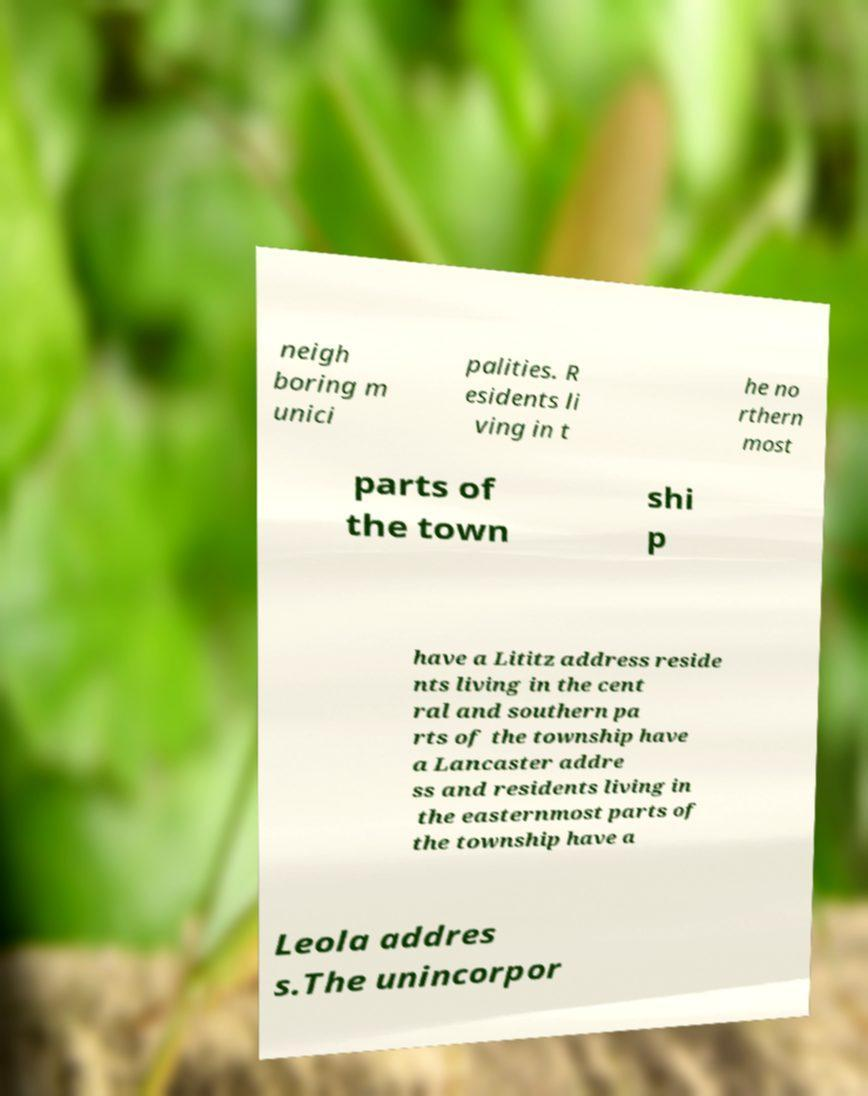Please identify and transcribe the text found in this image. neigh boring m unici palities. R esidents li ving in t he no rthern most parts of the town shi p have a Lititz address reside nts living in the cent ral and southern pa rts of the township have a Lancaster addre ss and residents living in the easternmost parts of the township have a Leola addres s.The unincorpor 